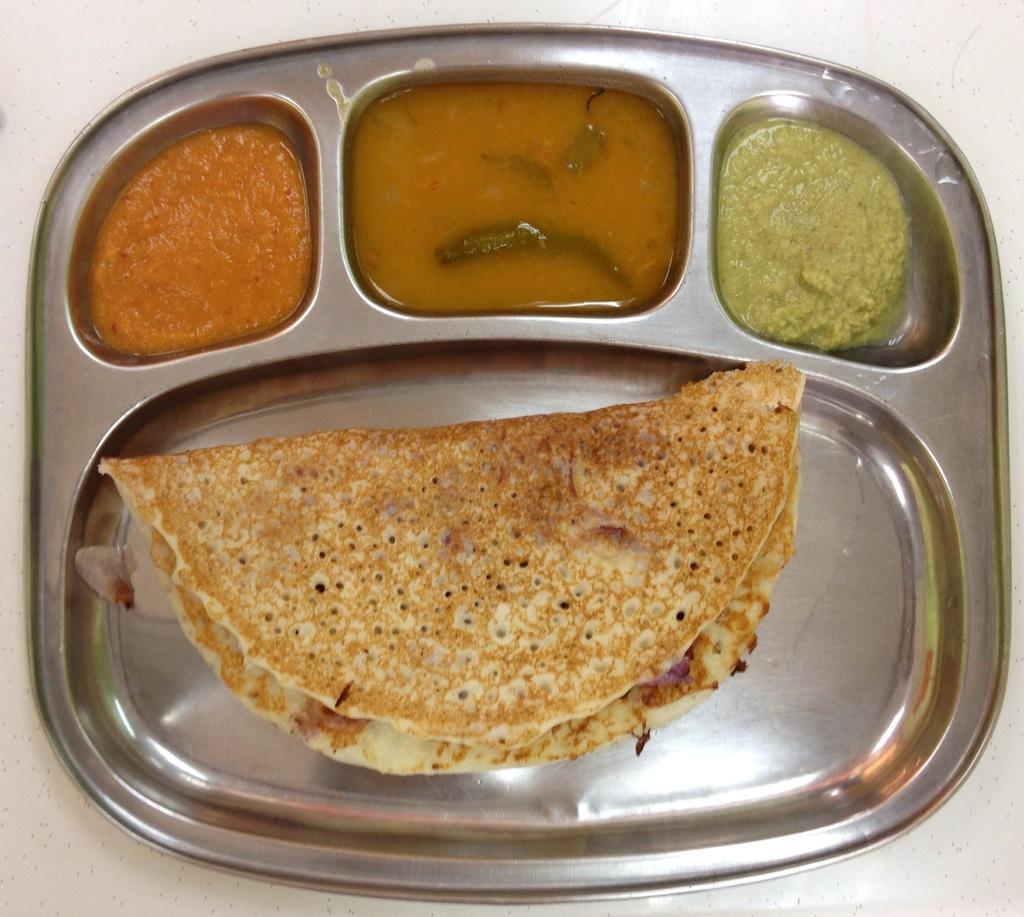In one or two sentences, can you explain what this image depicts? Here we can see a plate with a food item,two chutneys and a liquid food item in it on a platform. 